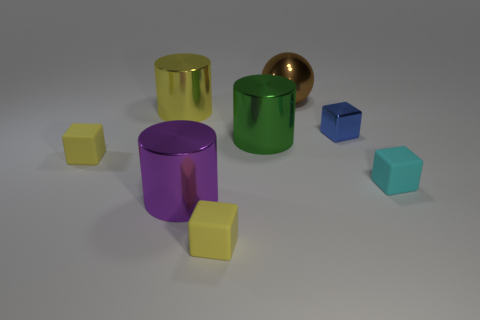What number of other things are the same size as the brown metallic thing?
Make the answer very short. 3. What material is the small object to the left of the yellow object to the right of the large yellow metallic cylinder in front of the large ball?
Offer a terse response. Rubber. Does the metal cube have the same size as the cylinder that is behind the small blue block?
Offer a very short reply. No. There is a object that is both to the right of the big purple object and in front of the small cyan block; what size is it?
Provide a succinct answer. Small. Are there any rubber cylinders of the same color as the small shiny cube?
Ensure brevity in your answer.  No. What is the color of the small matte block that is on the left side of the yellow metallic object to the left of the large brown object?
Your response must be concise. Yellow. Are there fewer brown metal objects that are behind the green cylinder than metallic objects that are on the left side of the tiny blue block?
Provide a succinct answer. Yes. Do the yellow metallic cylinder and the blue cube have the same size?
Provide a succinct answer. No. There is a metallic thing that is left of the large green metallic object and behind the purple shiny cylinder; what is its shape?
Make the answer very short. Cylinder. How many green objects have the same material as the big brown ball?
Your answer should be compact. 1. 